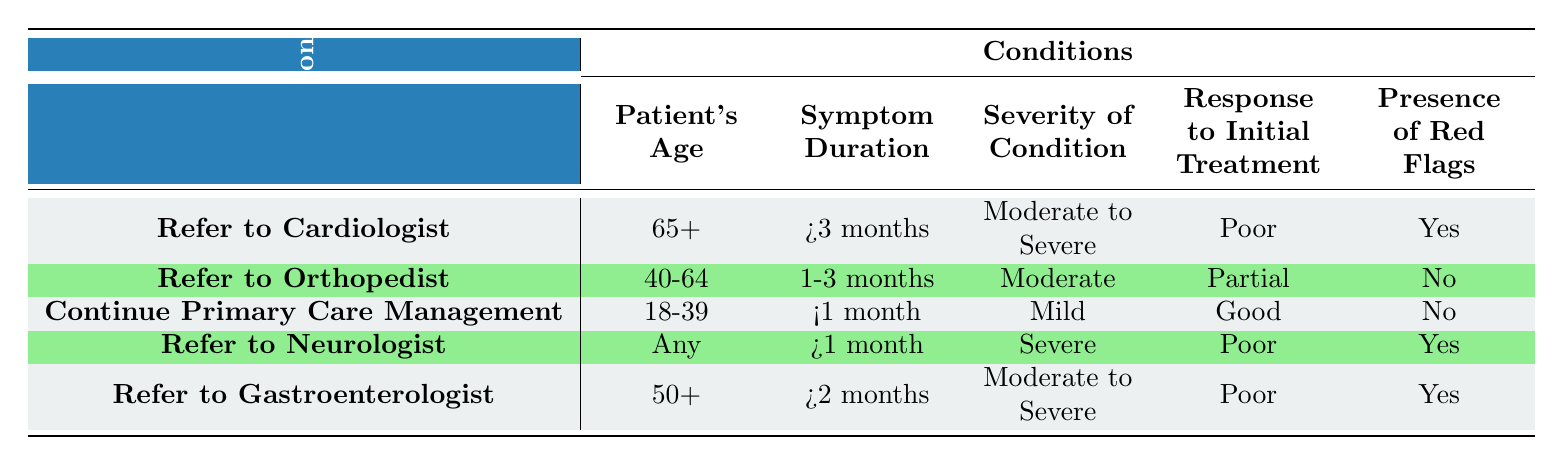What is the recommendation for a patient aged 65 or older with symptoms lasting more than 3 months, experiencing moderate to severe conditions, with a poor response to initial treatment and presence of red flags? According to the table, the criteria for referral in this case include being aged 65 or older, experiencing symptoms for more than 3 months, having a moderate to severe condition, showing a poor response to initial treatment, and having red flags present. Together, these conditions correspond to the recommendation to "Refer to Cardiologist."
Answer: Refer to Cardiologist What should be done for a patient aged 40-64 with moderate symptoms lasting 1-3 months, showing a partial response to initial treatment, and without red flags? The table indicates that for a patient aged between 40-64 with a symptom duration of 1-3 months, having moderate severity, a partial response to treatment, and no red flags, the recommendation is to "Refer to Orthopedist."
Answer: Refer to Orthopedist Is it recommended to refer patients aged 18-39 with mild symptoms that last less than 1 month to a specialist? The table shows that patients aged 18-39 with mild symptoms lasting less than 1 month and a good response to initial treatment without red flags are advised to continue with primary care management, not referral.
Answer: No For patients showing poor response to initial treatment with severe conditions for more than 1 month and with red flags, what is the recommendation regardless of age? The criteria in the table indicate that for any patient experiencing severe conditions for over 1 month, a poor response to treatment, and having red flags present, the recommendation is to "Refer to Neurologist." This applies regardless of age.
Answer: Refer to Neurologist Given a patient aged 50 or older with moderate to severe symptoms lasting more than 2 months, a poor response to initial treatment, and the presence of red flags, what is the medical recommendation? According to the table, a patient in this age group with the specified symptoms fits the criteria for referral to a gastroenterologist due to poor response to treatment and red flag presence. The recommendation here is to "Refer to Gastroenterologist."
Answer: Refer to Gastroenterologist What is the total number of specific recommendations categorized as referral to specialists in the table? The table lists 5 different referral recommendations: to a Cardiologist, Orthopedist, Neurologist, and Gastroenterologist, plus continuing primary care management. Thus, there are 4 specific referrals to specialists.
Answer: 4 Is there any scenario detailed in the table where specialists are not recommended? Yes, the table notes that for patients aged 18-39 with mild symptoms lasting less than 1 month, a good response to treatment, and no red flags, the recommendation is to continue with primary care management instead of referring to a specialist.
Answer: Yes How many different age categories are covered in the referral criteria presented in the table? The criteria in the table specify three distinct age brackets: "65+", "40-64", and "18-39." Additionally, one rule applies to "Any" age, making it four categories in total.
Answer: 4 